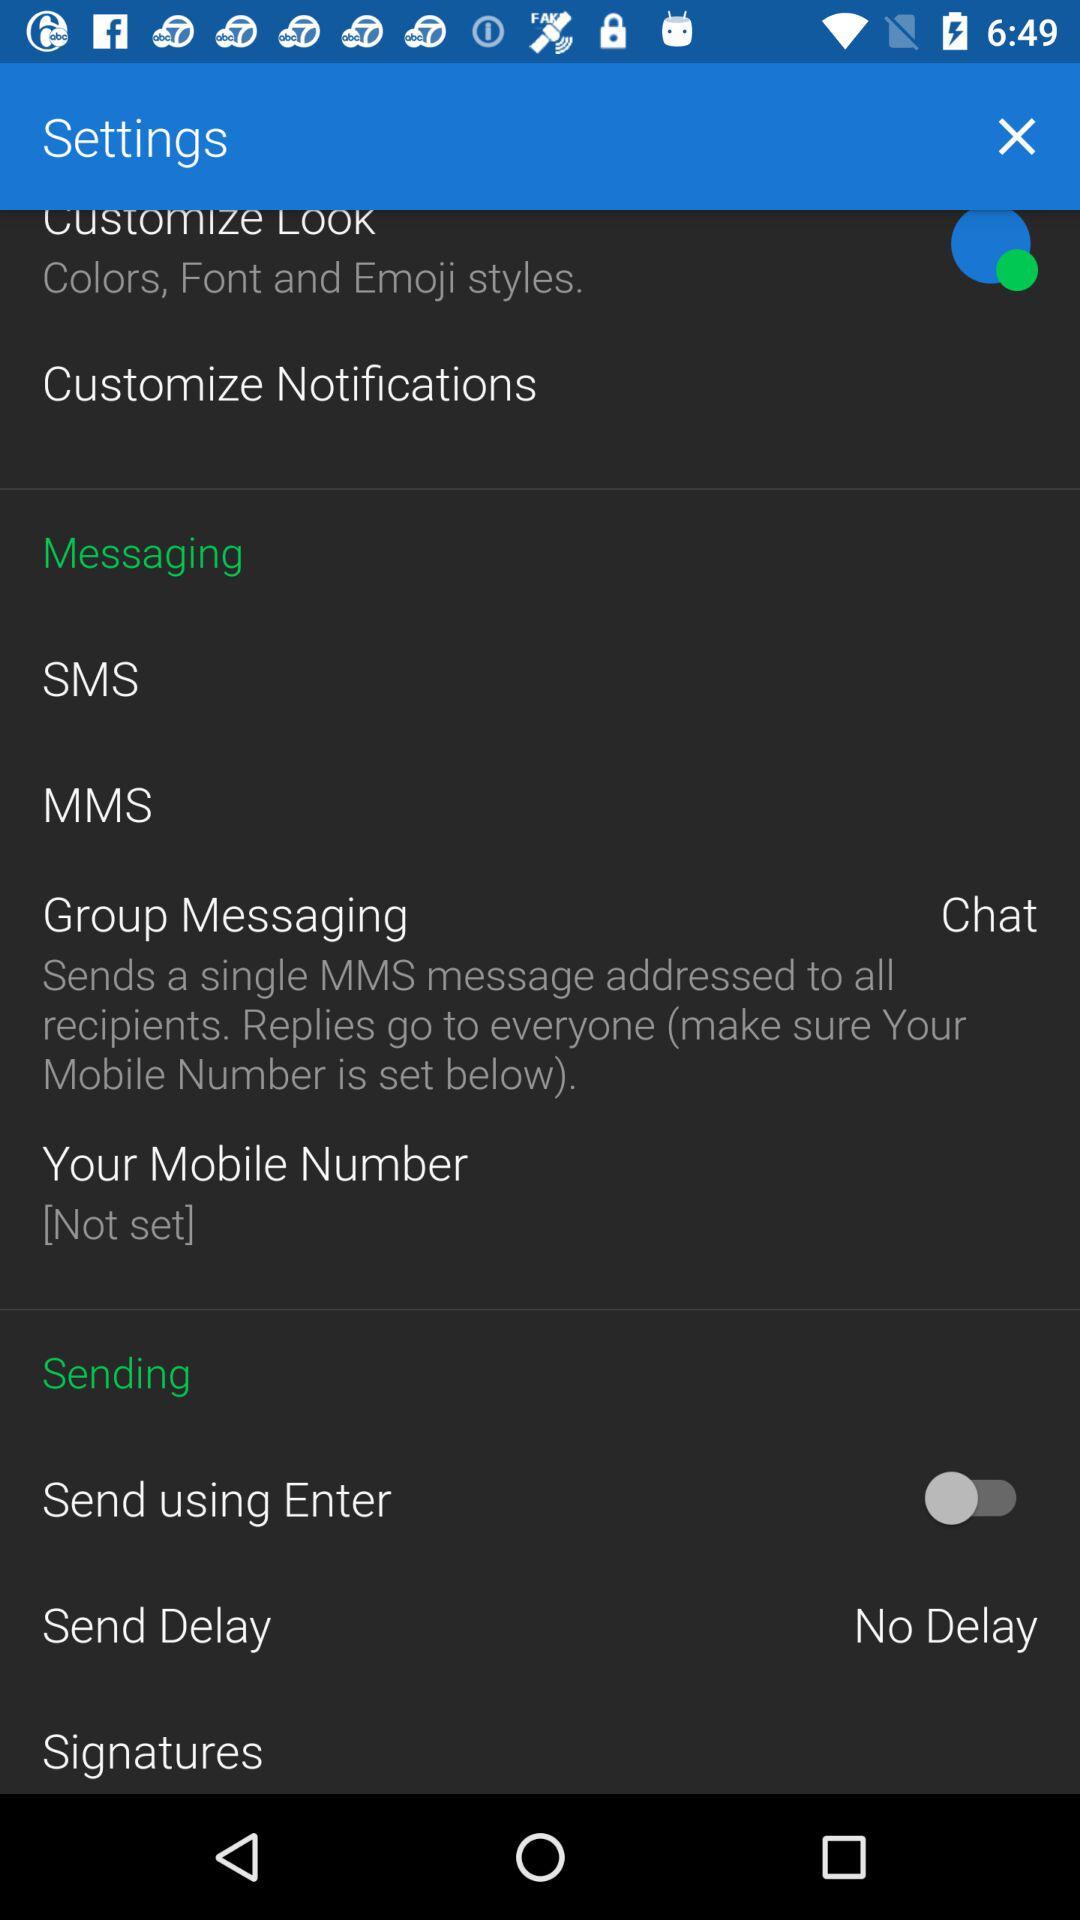What is the status of the message "Send using Enter"? The status is "off". 